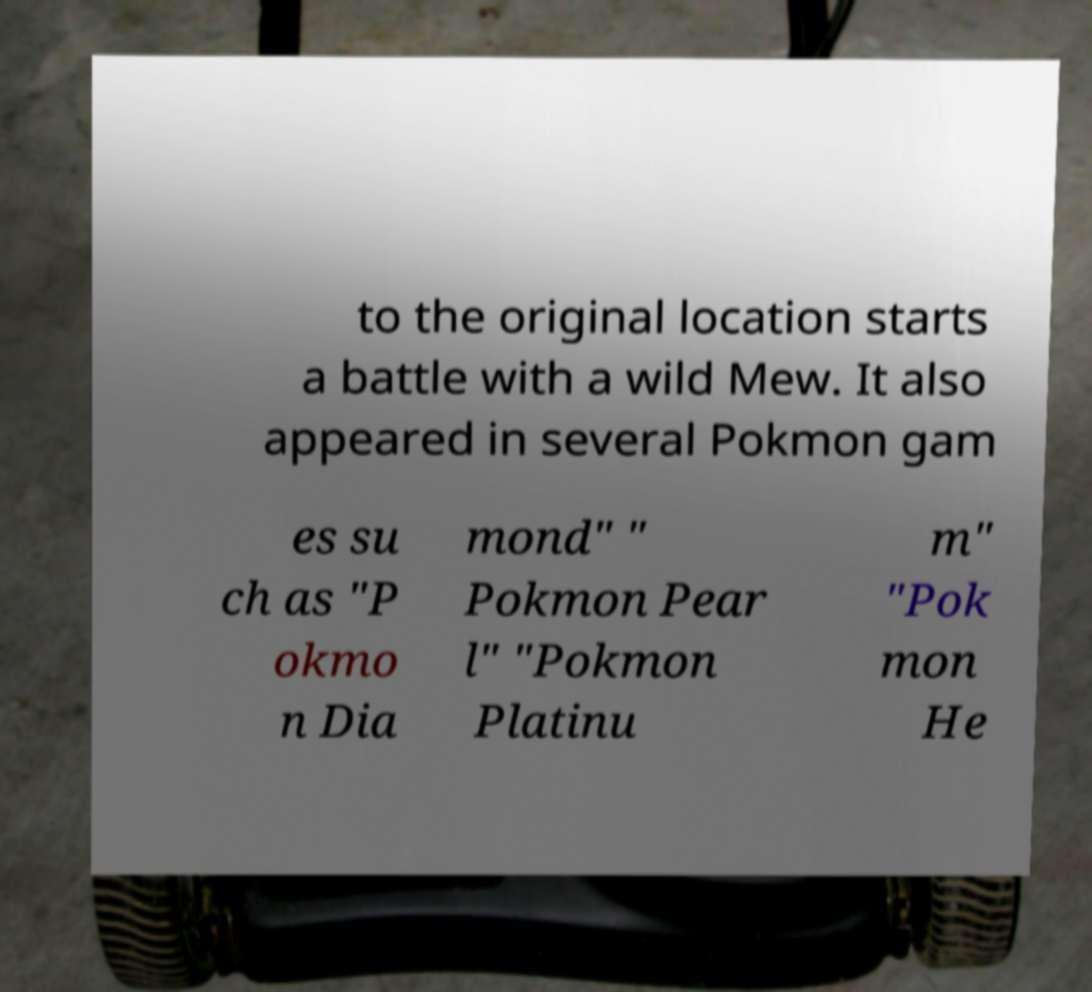I need the written content from this picture converted into text. Can you do that? to the original location starts a battle with a wild Mew. It also appeared in several Pokmon gam es su ch as "P okmo n Dia mond" " Pokmon Pear l" "Pokmon Platinu m" "Pok mon He 